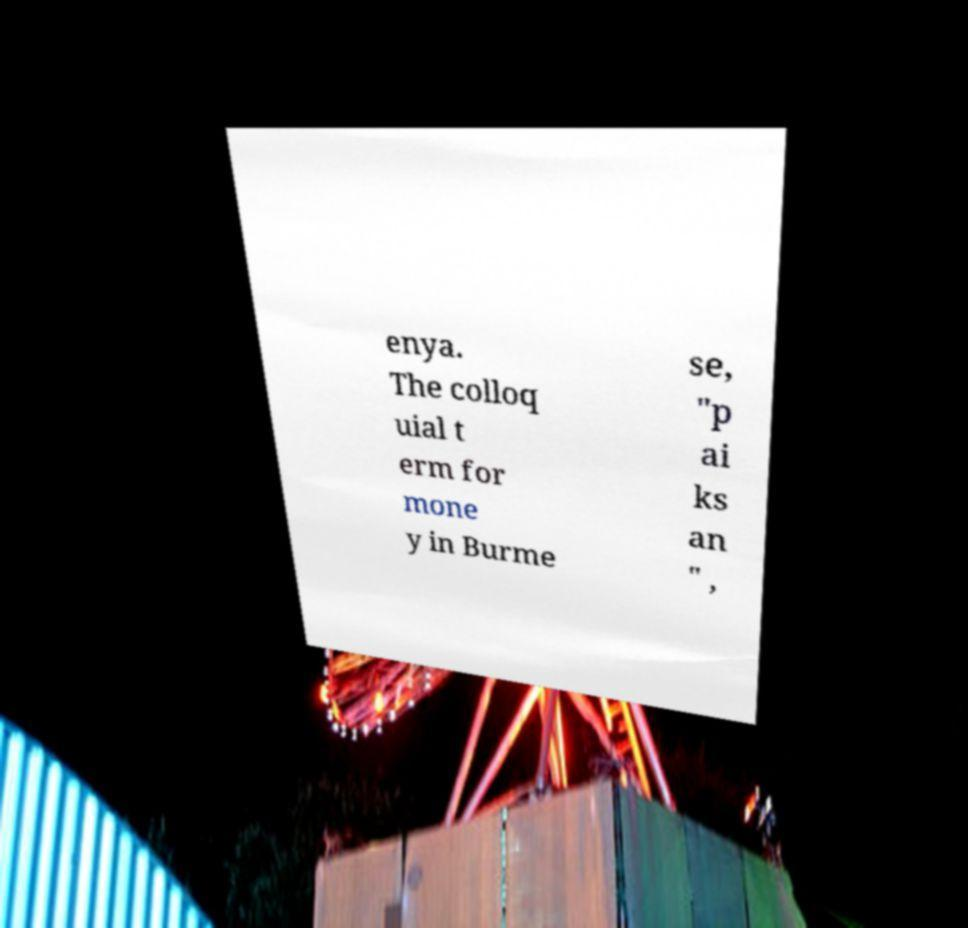Could you extract and type out the text from this image? enya. The colloq uial t erm for mone y in Burme se, "p ai ks an " , 